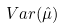Convert formula to latex. <formula><loc_0><loc_0><loc_500><loc_500>V a r ( \hat { \mu } )</formula> 